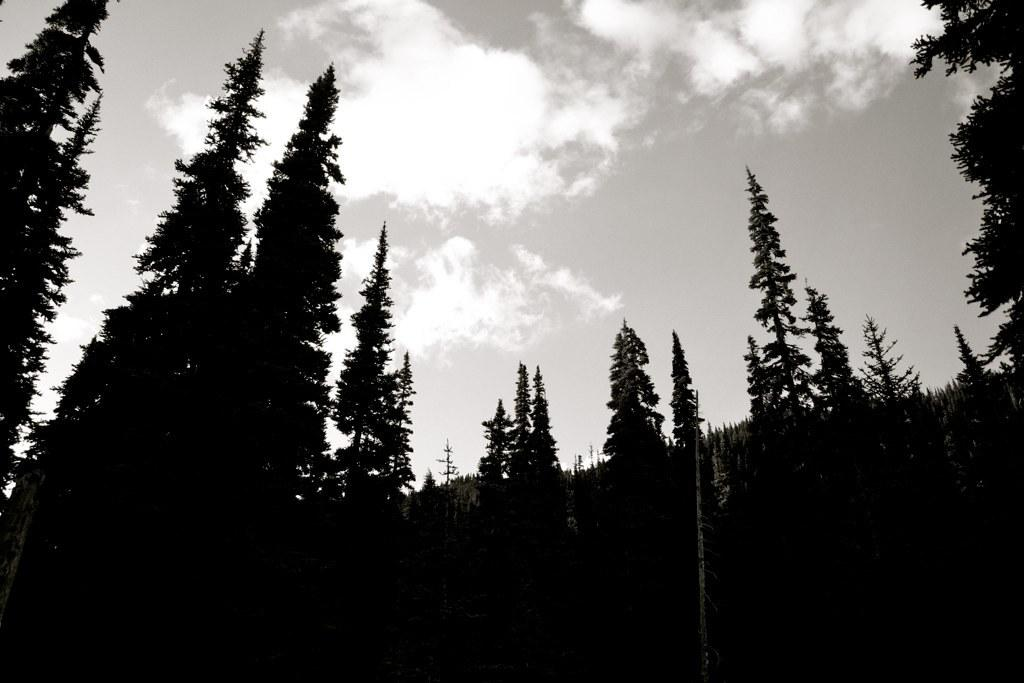What is the color scheme of the image? The image is black and white. What type of natural elements can be seen in the image? There are trees visible in the image. What is visible in the sky in the image? Clouds are present in the sky in the image. Can you tell me how many plants are hanging from the swing in the image? There is no swing or plants hanging from it present in the image; it is a black and white image with trees and clouds. 